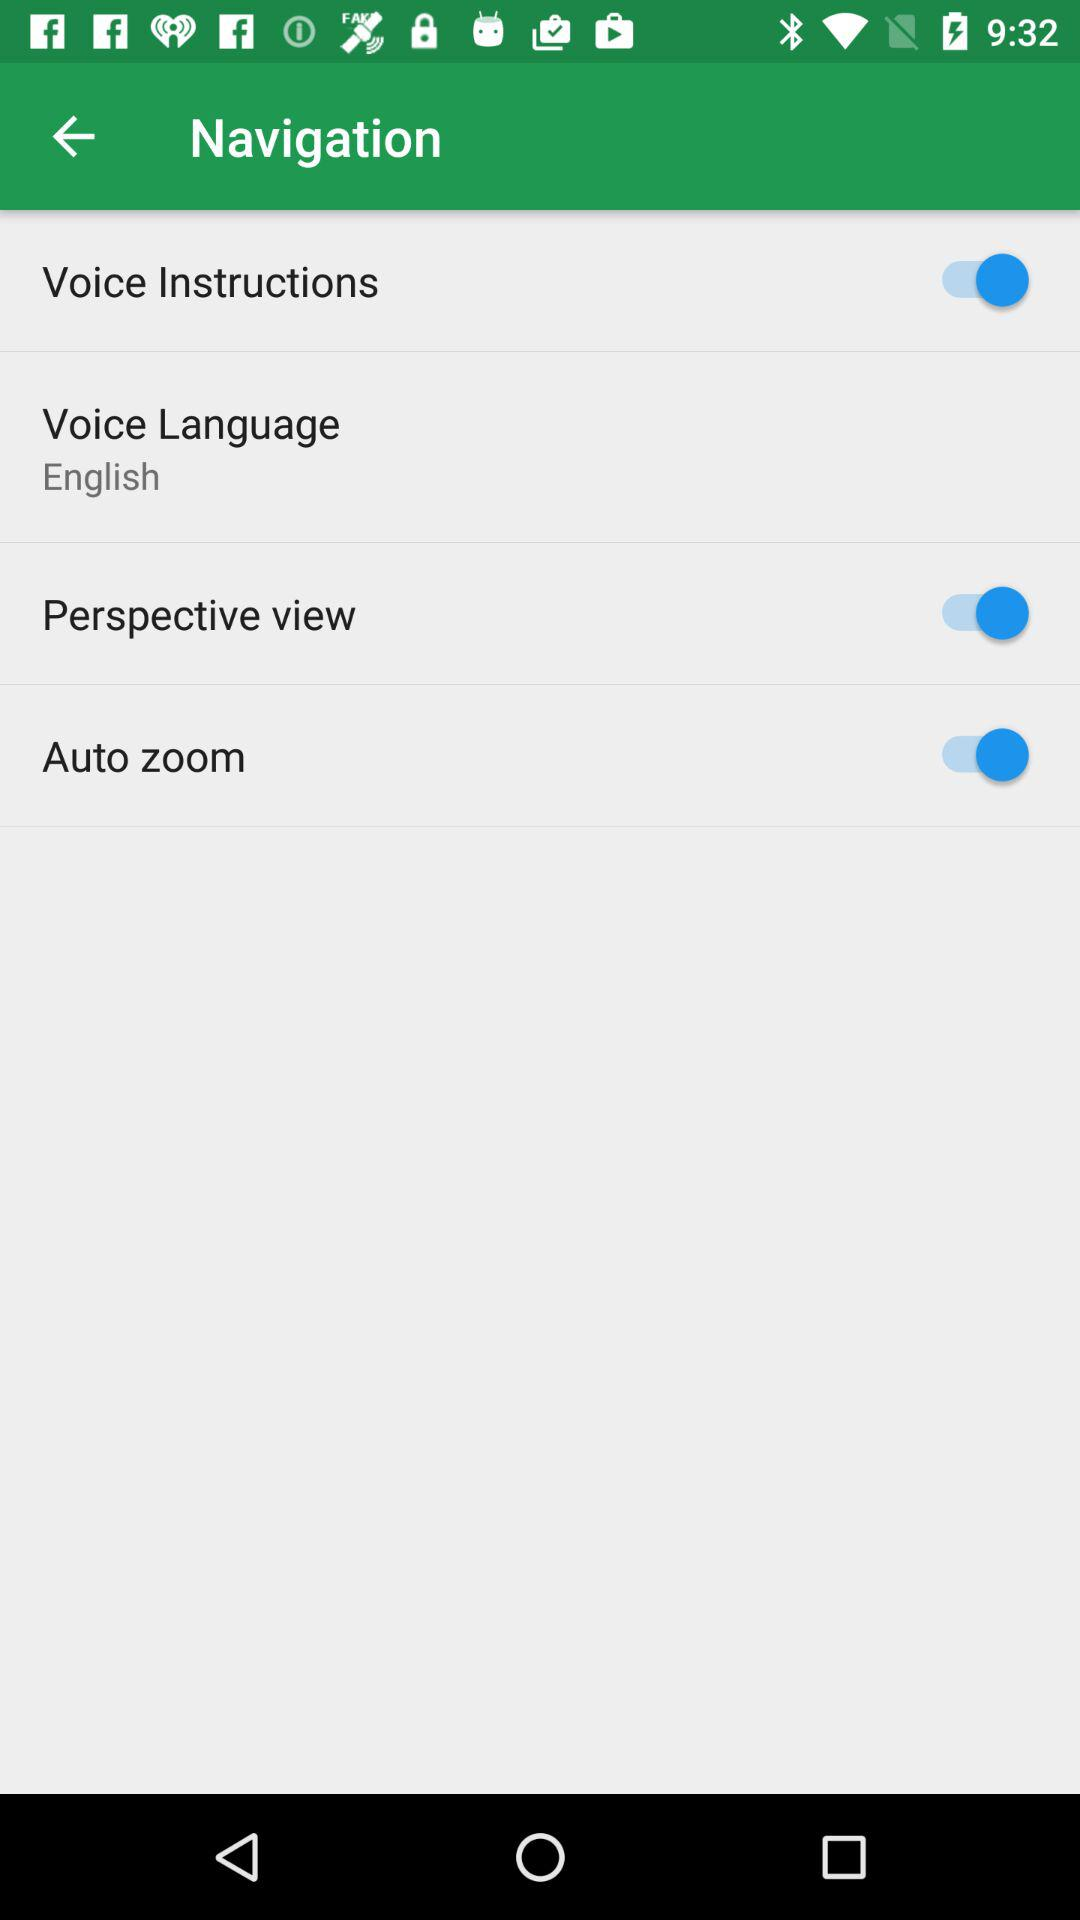What language is selected for "Voice language"? The selected language is "English". 